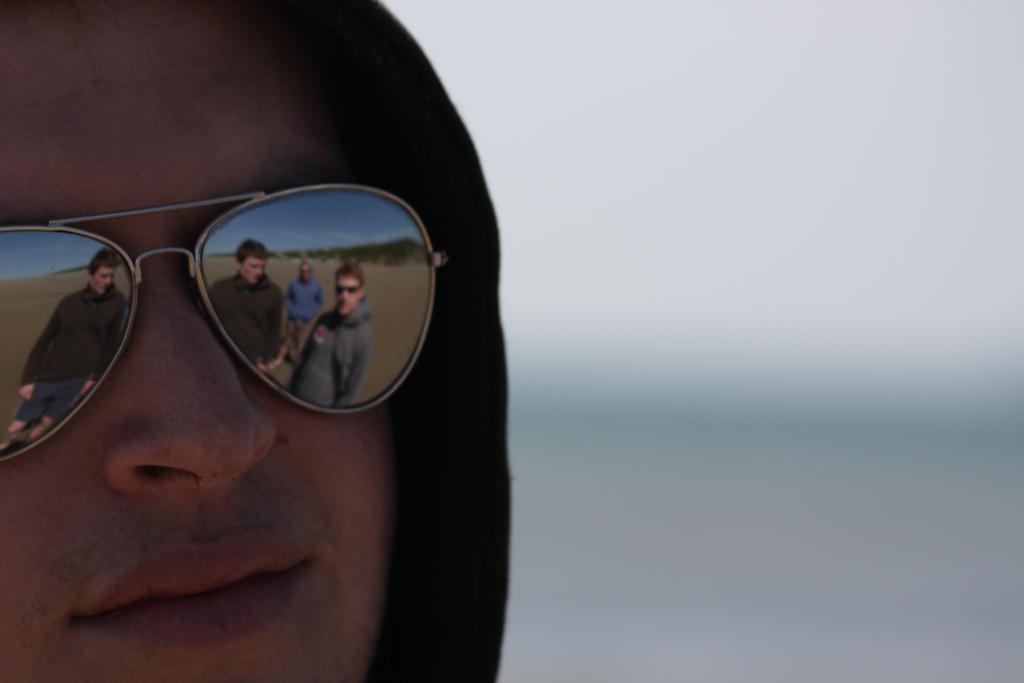Can you describe this image briefly? In this image we can see a person wearing goggles. We can see the reflection of few people, there are many trees and the sky on the goggles. There is a blur background at the right side of the image. 